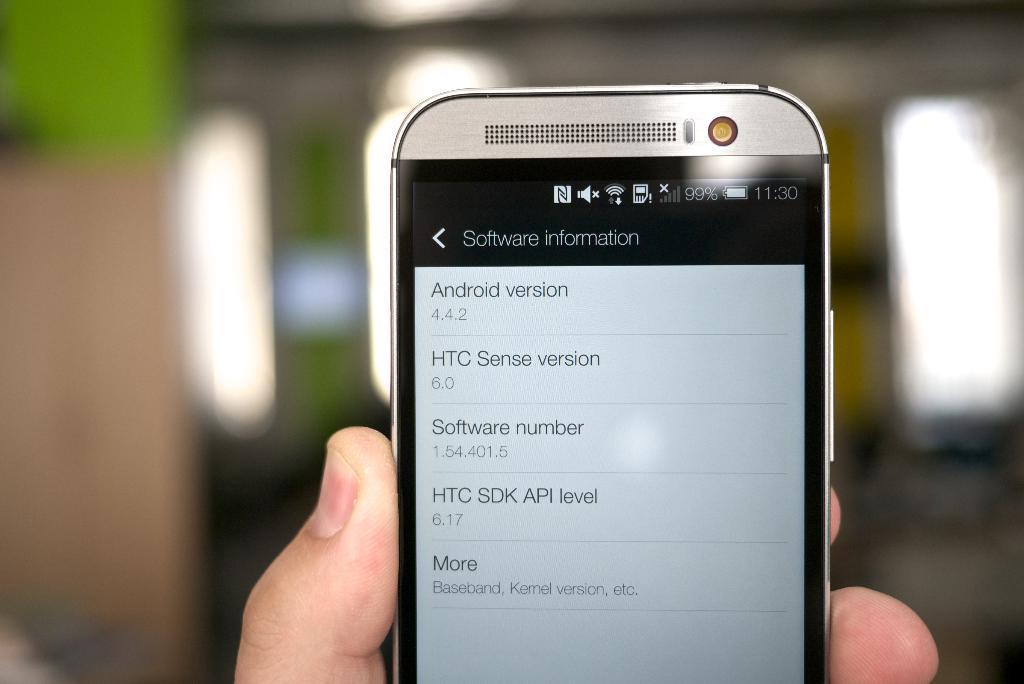How would you summarize this image in a sentence or two? In this image in the middle, there is a person hand holding a mobile phone on that there is a text. In the background there are lights. 